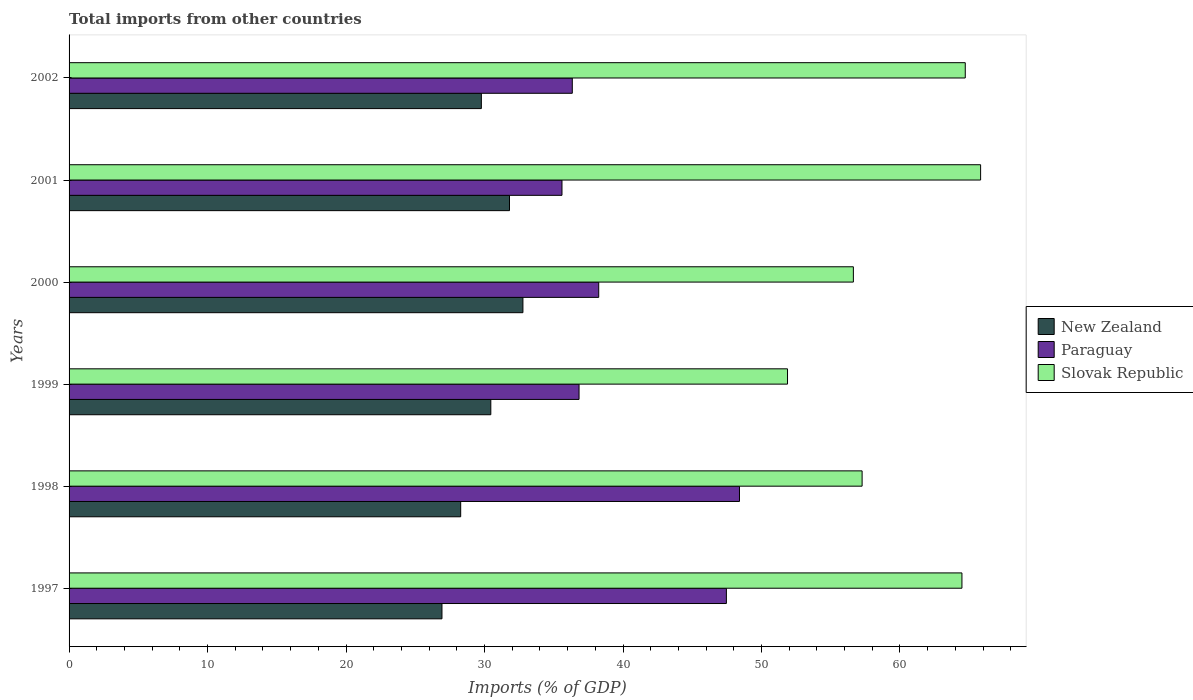How many groups of bars are there?
Keep it short and to the point. 6. How many bars are there on the 2nd tick from the top?
Your answer should be compact. 3. In how many cases, is the number of bars for a given year not equal to the number of legend labels?
Give a very brief answer. 0. What is the total imports in Slovak Republic in 2000?
Offer a very short reply. 56.63. Across all years, what is the maximum total imports in Slovak Republic?
Offer a terse response. 65.82. Across all years, what is the minimum total imports in New Zealand?
Your response must be concise. 26.93. What is the total total imports in Paraguay in the graph?
Make the answer very short. 242.88. What is the difference between the total imports in Slovak Republic in 1999 and that in 2002?
Give a very brief answer. -12.84. What is the difference between the total imports in Paraguay in 2000 and the total imports in New Zealand in 1997?
Make the answer very short. 11.32. What is the average total imports in New Zealand per year?
Your answer should be compact. 30. In the year 1997, what is the difference between the total imports in Slovak Republic and total imports in New Zealand?
Your answer should be compact. 37.55. In how many years, is the total imports in Paraguay greater than 2 %?
Offer a terse response. 6. What is the ratio of the total imports in Slovak Republic in 1997 to that in 1999?
Ensure brevity in your answer.  1.24. What is the difference between the highest and the second highest total imports in New Zealand?
Your answer should be very brief. 0.97. What is the difference between the highest and the lowest total imports in Slovak Republic?
Your response must be concise. 13.94. What does the 1st bar from the top in 2001 represents?
Ensure brevity in your answer.  Slovak Republic. What does the 3rd bar from the bottom in 1999 represents?
Your answer should be very brief. Slovak Republic. How many bars are there?
Your answer should be compact. 18. Are all the bars in the graph horizontal?
Ensure brevity in your answer.  Yes. What is the difference between two consecutive major ticks on the X-axis?
Offer a very short reply. 10. Are the values on the major ticks of X-axis written in scientific E-notation?
Your answer should be compact. No. Does the graph contain any zero values?
Provide a succinct answer. No. Does the graph contain grids?
Your answer should be compact. No. Where does the legend appear in the graph?
Your answer should be very brief. Center right. What is the title of the graph?
Give a very brief answer. Total imports from other countries. What is the label or title of the X-axis?
Give a very brief answer. Imports (% of GDP). What is the label or title of the Y-axis?
Offer a very short reply. Years. What is the Imports (% of GDP) in New Zealand in 1997?
Make the answer very short. 26.93. What is the Imports (% of GDP) of Paraguay in 1997?
Offer a terse response. 47.46. What is the Imports (% of GDP) of Slovak Republic in 1997?
Your answer should be very brief. 64.47. What is the Imports (% of GDP) in New Zealand in 1998?
Make the answer very short. 28.28. What is the Imports (% of GDP) in Paraguay in 1998?
Your answer should be very brief. 48.41. What is the Imports (% of GDP) in Slovak Republic in 1998?
Your response must be concise. 57.27. What is the Imports (% of GDP) in New Zealand in 1999?
Your answer should be very brief. 30.45. What is the Imports (% of GDP) in Paraguay in 1999?
Give a very brief answer. 36.83. What is the Imports (% of GDP) in Slovak Republic in 1999?
Offer a very short reply. 51.88. What is the Imports (% of GDP) in New Zealand in 2000?
Provide a succinct answer. 32.77. What is the Imports (% of GDP) of Paraguay in 2000?
Offer a terse response. 38.25. What is the Imports (% of GDP) of Slovak Republic in 2000?
Offer a terse response. 56.63. What is the Imports (% of GDP) in New Zealand in 2001?
Your answer should be compact. 31.8. What is the Imports (% of GDP) in Paraguay in 2001?
Offer a terse response. 35.59. What is the Imports (% of GDP) of Slovak Republic in 2001?
Provide a succinct answer. 65.82. What is the Imports (% of GDP) in New Zealand in 2002?
Provide a short and direct response. 29.77. What is the Imports (% of GDP) in Paraguay in 2002?
Offer a very short reply. 36.34. What is the Imports (% of GDP) of Slovak Republic in 2002?
Offer a terse response. 64.71. Across all years, what is the maximum Imports (% of GDP) of New Zealand?
Your response must be concise. 32.77. Across all years, what is the maximum Imports (% of GDP) in Paraguay?
Your response must be concise. 48.41. Across all years, what is the maximum Imports (% of GDP) of Slovak Republic?
Ensure brevity in your answer.  65.82. Across all years, what is the minimum Imports (% of GDP) in New Zealand?
Your response must be concise. 26.93. Across all years, what is the minimum Imports (% of GDP) of Paraguay?
Provide a succinct answer. 35.59. Across all years, what is the minimum Imports (% of GDP) of Slovak Republic?
Your answer should be very brief. 51.88. What is the total Imports (% of GDP) of New Zealand in the graph?
Make the answer very short. 180. What is the total Imports (% of GDP) of Paraguay in the graph?
Ensure brevity in your answer.  242.88. What is the total Imports (% of GDP) in Slovak Republic in the graph?
Provide a succinct answer. 360.78. What is the difference between the Imports (% of GDP) in New Zealand in 1997 and that in 1998?
Offer a terse response. -1.35. What is the difference between the Imports (% of GDP) in Paraguay in 1997 and that in 1998?
Provide a succinct answer. -0.95. What is the difference between the Imports (% of GDP) of Slovak Republic in 1997 and that in 1998?
Provide a short and direct response. 7.21. What is the difference between the Imports (% of GDP) in New Zealand in 1997 and that in 1999?
Ensure brevity in your answer.  -3.53. What is the difference between the Imports (% of GDP) of Paraguay in 1997 and that in 1999?
Provide a succinct answer. 10.64. What is the difference between the Imports (% of GDP) of Slovak Republic in 1997 and that in 1999?
Keep it short and to the point. 12.6. What is the difference between the Imports (% of GDP) of New Zealand in 1997 and that in 2000?
Your response must be concise. -5.85. What is the difference between the Imports (% of GDP) of Paraguay in 1997 and that in 2000?
Provide a short and direct response. 9.22. What is the difference between the Imports (% of GDP) of Slovak Republic in 1997 and that in 2000?
Provide a succinct answer. 7.84. What is the difference between the Imports (% of GDP) of New Zealand in 1997 and that in 2001?
Give a very brief answer. -4.88. What is the difference between the Imports (% of GDP) of Paraguay in 1997 and that in 2001?
Keep it short and to the point. 11.87. What is the difference between the Imports (% of GDP) in Slovak Republic in 1997 and that in 2001?
Ensure brevity in your answer.  -1.35. What is the difference between the Imports (% of GDP) of New Zealand in 1997 and that in 2002?
Provide a short and direct response. -2.85. What is the difference between the Imports (% of GDP) in Paraguay in 1997 and that in 2002?
Provide a short and direct response. 11.13. What is the difference between the Imports (% of GDP) of Slovak Republic in 1997 and that in 2002?
Provide a succinct answer. -0.24. What is the difference between the Imports (% of GDP) in New Zealand in 1998 and that in 1999?
Keep it short and to the point. -2.18. What is the difference between the Imports (% of GDP) of Paraguay in 1998 and that in 1999?
Provide a short and direct response. 11.58. What is the difference between the Imports (% of GDP) of Slovak Republic in 1998 and that in 1999?
Offer a very short reply. 5.39. What is the difference between the Imports (% of GDP) of New Zealand in 1998 and that in 2000?
Your response must be concise. -4.49. What is the difference between the Imports (% of GDP) in Paraguay in 1998 and that in 2000?
Provide a short and direct response. 10.16. What is the difference between the Imports (% of GDP) of Slovak Republic in 1998 and that in 2000?
Keep it short and to the point. 0.63. What is the difference between the Imports (% of GDP) in New Zealand in 1998 and that in 2001?
Offer a terse response. -3.52. What is the difference between the Imports (% of GDP) of Paraguay in 1998 and that in 2001?
Your answer should be very brief. 12.82. What is the difference between the Imports (% of GDP) of Slovak Republic in 1998 and that in 2001?
Offer a very short reply. -8.56. What is the difference between the Imports (% of GDP) in New Zealand in 1998 and that in 2002?
Offer a very short reply. -1.49. What is the difference between the Imports (% of GDP) in Paraguay in 1998 and that in 2002?
Your answer should be very brief. 12.07. What is the difference between the Imports (% of GDP) of Slovak Republic in 1998 and that in 2002?
Provide a short and direct response. -7.45. What is the difference between the Imports (% of GDP) in New Zealand in 1999 and that in 2000?
Make the answer very short. -2.32. What is the difference between the Imports (% of GDP) in Paraguay in 1999 and that in 2000?
Make the answer very short. -1.42. What is the difference between the Imports (% of GDP) of Slovak Republic in 1999 and that in 2000?
Offer a very short reply. -4.76. What is the difference between the Imports (% of GDP) of New Zealand in 1999 and that in 2001?
Provide a succinct answer. -1.35. What is the difference between the Imports (% of GDP) in Paraguay in 1999 and that in 2001?
Give a very brief answer. 1.23. What is the difference between the Imports (% of GDP) in Slovak Republic in 1999 and that in 2001?
Offer a very short reply. -13.94. What is the difference between the Imports (% of GDP) of New Zealand in 1999 and that in 2002?
Your answer should be compact. 0.68. What is the difference between the Imports (% of GDP) of Paraguay in 1999 and that in 2002?
Offer a very short reply. 0.49. What is the difference between the Imports (% of GDP) of Slovak Republic in 1999 and that in 2002?
Offer a terse response. -12.84. What is the difference between the Imports (% of GDP) of New Zealand in 2000 and that in 2001?
Offer a terse response. 0.97. What is the difference between the Imports (% of GDP) of Paraguay in 2000 and that in 2001?
Provide a short and direct response. 2.65. What is the difference between the Imports (% of GDP) in Slovak Republic in 2000 and that in 2001?
Keep it short and to the point. -9.19. What is the difference between the Imports (% of GDP) of New Zealand in 2000 and that in 2002?
Your answer should be compact. 3. What is the difference between the Imports (% of GDP) of Paraguay in 2000 and that in 2002?
Offer a very short reply. 1.91. What is the difference between the Imports (% of GDP) of Slovak Republic in 2000 and that in 2002?
Your response must be concise. -8.08. What is the difference between the Imports (% of GDP) of New Zealand in 2001 and that in 2002?
Your answer should be very brief. 2.03. What is the difference between the Imports (% of GDP) of Paraguay in 2001 and that in 2002?
Your response must be concise. -0.74. What is the difference between the Imports (% of GDP) of Slovak Republic in 2001 and that in 2002?
Offer a terse response. 1.11. What is the difference between the Imports (% of GDP) in New Zealand in 1997 and the Imports (% of GDP) in Paraguay in 1998?
Keep it short and to the point. -21.48. What is the difference between the Imports (% of GDP) in New Zealand in 1997 and the Imports (% of GDP) in Slovak Republic in 1998?
Your response must be concise. -30.34. What is the difference between the Imports (% of GDP) of Paraguay in 1997 and the Imports (% of GDP) of Slovak Republic in 1998?
Offer a very short reply. -9.8. What is the difference between the Imports (% of GDP) of New Zealand in 1997 and the Imports (% of GDP) of Paraguay in 1999?
Provide a succinct answer. -9.9. What is the difference between the Imports (% of GDP) in New Zealand in 1997 and the Imports (% of GDP) in Slovak Republic in 1999?
Provide a short and direct response. -24.95. What is the difference between the Imports (% of GDP) of Paraguay in 1997 and the Imports (% of GDP) of Slovak Republic in 1999?
Your answer should be compact. -4.41. What is the difference between the Imports (% of GDP) in New Zealand in 1997 and the Imports (% of GDP) in Paraguay in 2000?
Give a very brief answer. -11.32. What is the difference between the Imports (% of GDP) in New Zealand in 1997 and the Imports (% of GDP) in Slovak Republic in 2000?
Your answer should be very brief. -29.71. What is the difference between the Imports (% of GDP) in Paraguay in 1997 and the Imports (% of GDP) in Slovak Republic in 2000?
Give a very brief answer. -9.17. What is the difference between the Imports (% of GDP) of New Zealand in 1997 and the Imports (% of GDP) of Paraguay in 2001?
Offer a very short reply. -8.67. What is the difference between the Imports (% of GDP) in New Zealand in 1997 and the Imports (% of GDP) in Slovak Republic in 2001?
Make the answer very short. -38.89. What is the difference between the Imports (% of GDP) of Paraguay in 1997 and the Imports (% of GDP) of Slovak Republic in 2001?
Ensure brevity in your answer.  -18.36. What is the difference between the Imports (% of GDP) of New Zealand in 1997 and the Imports (% of GDP) of Paraguay in 2002?
Your response must be concise. -9.41. What is the difference between the Imports (% of GDP) in New Zealand in 1997 and the Imports (% of GDP) in Slovak Republic in 2002?
Provide a succinct answer. -37.79. What is the difference between the Imports (% of GDP) in Paraguay in 1997 and the Imports (% of GDP) in Slovak Republic in 2002?
Make the answer very short. -17.25. What is the difference between the Imports (% of GDP) in New Zealand in 1998 and the Imports (% of GDP) in Paraguay in 1999?
Your response must be concise. -8.55. What is the difference between the Imports (% of GDP) in New Zealand in 1998 and the Imports (% of GDP) in Slovak Republic in 1999?
Give a very brief answer. -23.6. What is the difference between the Imports (% of GDP) in Paraguay in 1998 and the Imports (% of GDP) in Slovak Republic in 1999?
Your answer should be compact. -3.47. What is the difference between the Imports (% of GDP) of New Zealand in 1998 and the Imports (% of GDP) of Paraguay in 2000?
Provide a succinct answer. -9.97. What is the difference between the Imports (% of GDP) in New Zealand in 1998 and the Imports (% of GDP) in Slovak Republic in 2000?
Keep it short and to the point. -28.36. What is the difference between the Imports (% of GDP) of Paraguay in 1998 and the Imports (% of GDP) of Slovak Republic in 2000?
Offer a terse response. -8.22. What is the difference between the Imports (% of GDP) in New Zealand in 1998 and the Imports (% of GDP) in Paraguay in 2001?
Your answer should be compact. -7.31. What is the difference between the Imports (% of GDP) of New Zealand in 1998 and the Imports (% of GDP) of Slovak Republic in 2001?
Offer a terse response. -37.54. What is the difference between the Imports (% of GDP) in Paraguay in 1998 and the Imports (% of GDP) in Slovak Republic in 2001?
Your answer should be very brief. -17.41. What is the difference between the Imports (% of GDP) in New Zealand in 1998 and the Imports (% of GDP) in Paraguay in 2002?
Offer a very short reply. -8.06. What is the difference between the Imports (% of GDP) of New Zealand in 1998 and the Imports (% of GDP) of Slovak Republic in 2002?
Your answer should be very brief. -36.44. What is the difference between the Imports (% of GDP) of Paraguay in 1998 and the Imports (% of GDP) of Slovak Republic in 2002?
Offer a terse response. -16.3. What is the difference between the Imports (% of GDP) in New Zealand in 1999 and the Imports (% of GDP) in Paraguay in 2000?
Ensure brevity in your answer.  -7.79. What is the difference between the Imports (% of GDP) of New Zealand in 1999 and the Imports (% of GDP) of Slovak Republic in 2000?
Make the answer very short. -26.18. What is the difference between the Imports (% of GDP) of Paraguay in 1999 and the Imports (% of GDP) of Slovak Republic in 2000?
Ensure brevity in your answer.  -19.81. What is the difference between the Imports (% of GDP) in New Zealand in 1999 and the Imports (% of GDP) in Paraguay in 2001?
Give a very brief answer. -5.14. What is the difference between the Imports (% of GDP) of New Zealand in 1999 and the Imports (% of GDP) of Slovak Republic in 2001?
Provide a succinct answer. -35.37. What is the difference between the Imports (% of GDP) of Paraguay in 1999 and the Imports (% of GDP) of Slovak Republic in 2001?
Offer a terse response. -29. What is the difference between the Imports (% of GDP) in New Zealand in 1999 and the Imports (% of GDP) in Paraguay in 2002?
Offer a very short reply. -5.88. What is the difference between the Imports (% of GDP) of New Zealand in 1999 and the Imports (% of GDP) of Slovak Republic in 2002?
Give a very brief answer. -34.26. What is the difference between the Imports (% of GDP) of Paraguay in 1999 and the Imports (% of GDP) of Slovak Republic in 2002?
Keep it short and to the point. -27.89. What is the difference between the Imports (% of GDP) in New Zealand in 2000 and the Imports (% of GDP) in Paraguay in 2001?
Ensure brevity in your answer.  -2.82. What is the difference between the Imports (% of GDP) in New Zealand in 2000 and the Imports (% of GDP) in Slovak Republic in 2001?
Your response must be concise. -33.05. What is the difference between the Imports (% of GDP) of Paraguay in 2000 and the Imports (% of GDP) of Slovak Republic in 2001?
Offer a very short reply. -27.58. What is the difference between the Imports (% of GDP) of New Zealand in 2000 and the Imports (% of GDP) of Paraguay in 2002?
Keep it short and to the point. -3.57. What is the difference between the Imports (% of GDP) in New Zealand in 2000 and the Imports (% of GDP) in Slovak Republic in 2002?
Your response must be concise. -31.94. What is the difference between the Imports (% of GDP) of Paraguay in 2000 and the Imports (% of GDP) of Slovak Republic in 2002?
Ensure brevity in your answer.  -26.47. What is the difference between the Imports (% of GDP) in New Zealand in 2001 and the Imports (% of GDP) in Paraguay in 2002?
Offer a terse response. -4.53. What is the difference between the Imports (% of GDP) in New Zealand in 2001 and the Imports (% of GDP) in Slovak Republic in 2002?
Make the answer very short. -32.91. What is the difference between the Imports (% of GDP) in Paraguay in 2001 and the Imports (% of GDP) in Slovak Republic in 2002?
Offer a very short reply. -29.12. What is the average Imports (% of GDP) of New Zealand per year?
Your answer should be compact. 30. What is the average Imports (% of GDP) of Paraguay per year?
Make the answer very short. 40.48. What is the average Imports (% of GDP) in Slovak Republic per year?
Provide a succinct answer. 60.13. In the year 1997, what is the difference between the Imports (% of GDP) in New Zealand and Imports (% of GDP) in Paraguay?
Your answer should be compact. -20.54. In the year 1997, what is the difference between the Imports (% of GDP) of New Zealand and Imports (% of GDP) of Slovak Republic?
Provide a short and direct response. -37.55. In the year 1997, what is the difference between the Imports (% of GDP) in Paraguay and Imports (% of GDP) in Slovak Republic?
Your answer should be compact. -17.01. In the year 1998, what is the difference between the Imports (% of GDP) of New Zealand and Imports (% of GDP) of Paraguay?
Your answer should be very brief. -20.13. In the year 1998, what is the difference between the Imports (% of GDP) in New Zealand and Imports (% of GDP) in Slovak Republic?
Provide a succinct answer. -28.99. In the year 1998, what is the difference between the Imports (% of GDP) in Paraguay and Imports (% of GDP) in Slovak Republic?
Your answer should be compact. -8.86. In the year 1999, what is the difference between the Imports (% of GDP) in New Zealand and Imports (% of GDP) in Paraguay?
Ensure brevity in your answer.  -6.37. In the year 1999, what is the difference between the Imports (% of GDP) of New Zealand and Imports (% of GDP) of Slovak Republic?
Offer a terse response. -21.42. In the year 1999, what is the difference between the Imports (% of GDP) of Paraguay and Imports (% of GDP) of Slovak Republic?
Your response must be concise. -15.05. In the year 2000, what is the difference between the Imports (% of GDP) of New Zealand and Imports (% of GDP) of Paraguay?
Provide a short and direct response. -5.47. In the year 2000, what is the difference between the Imports (% of GDP) in New Zealand and Imports (% of GDP) in Slovak Republic?
Offer a very short reply. -23.86. In the year 2000, what is the difference between the Imports (% of GDP) in Paraguay and Imports (% of GDP) in Slovak Republic?
Keep it short and to the point. -18.39. In the year 2001, what is the difference between the Imports (% of GDP) of New Zealand and Imports (% of GDP) of Paraguay?
Ensure brevity in your answer.  -3.79. In the year 2001, what is the difference between the Imports (% of GDP) in New Zealand and Imports (% of GDP) in Slovak Republic?
Give a very brief answer. -34.02. In the year 2001, what is the difference between the Imports (% of GDP) of Paraguay and Imports (% of GDP) of Slovak Republic?
Your response must be concise. -30.23. In the year 2002, what is the difference between the Imports (% of GDP) of New Zealand and Imports (% of GDP) of Paraguay?
Your response must be concise. -6.57. In the year 2002, what is the difference between the Imports (% of GDP) in New Zealand and Imports (% of GDP) in Slovak Republic?
Ensure brevity in your answer.  -34.94. In the year 2002, what is the difference between the Imports (% of GDP) in Paraguay and Imports (% of GDP) in Slovak Republic?
Your answer should be very brief. -28.38. What is the ratio of the Imports (% of GDP) in New Zealand in 1997 to that in 1998?
Provide a succinct answer. 0.95. What is the ratio of the Imports (% of GDP) in Paraguay in 1997 to that in 1998?
Provide a short and direct response. 0.98. What is the ratio of the Imports (% of GDP) of Slovak Republic in 1997 to that in 1998?
Provide a short and direct response. 1.13. What is the ratio of the Imports (% of GDP) in New Zealand in 1997 to that in 1999?
Ensure brevity in your answer.  0.88. What is the ratio of the Imports (% of GDP) of Paraguay in 1997 to that in 1999?
Your answer should be compact. 1.29. What is the ratio of the Imports (% of GDP) in Slovak Republic in 1997 to that in 1999?
Your answer should be compact. 1.24. What is the ratio of the Imports (% of GDP) in New Zealand in 1997 to that in 2000?
Keep it short and to the point. 0.82. What is the ratio of the Imports (% of GDP) in Paraguay in 1997 to that in 2000?
Keep it short and to the point. 1.24. What is the ratio of the Imports (% of GDP) in Slovak Republic in 1997 to that in 2000?
Your response must be concise. 1.14. What is the ratio of the Imports (% of GDP) of New Zealand in 1997 to that in 2001?
Your answer should be compact. 0.85. What is the ratio of the Imports (% of GDP) in Paraguay in 1997 to that in 2001?
Provide a succinct answer. 1.33. What is the ratio of the Imports (% of GDP) in Slovak Republic in 1997 to that in 2001?
Your answer should be compact. 0.98. What is the ratio of the Imports (% of GDP) in New Zealand in 1997 to that in 2002?
Your response must be concise. 0.9. What is the ratio of the Imports (% of GDP) of Paraguay in 1997 to that in 2002?
Provide a succinct answer. 1.31. What is the ratio of the Imports (% of GDP) of Slovak Republic in 1997 to that in 2002?
Keep it short and to the point. 1. What is the ratio of the Imports (% of GDP) of Paraguay in 1998 to that in 1999?
Offer a terse response. 1.31. What is the ratio of the Imports (% of GDP) of Slovak Republic in 1998 to that in 1999?
Keep it short and to the point. 1.1. What is the ratio of the Imports (% of GDP) in New Zealand in 1998 to that in 2000?
Offer a very short reply. 0.86. What is the ratio of the Imports (% of GDP) of Paraguay in 1998 to that in 2000?
Make the answer very short. 1.27. What is the ratio of the Imports (% of GDP) in Slovak Republic in 1998 to that in 2000?
Your answer should be compact. 1.01. What is the ratio of the Imports (% of GDP) in New Zealand in 1998 to that in 2001?
Your answer should be compact. 0.89. What is the ratio of the Imports (% of GDP) of Paraguay in 1998 to that in 2001?
Provide a short and direct response. 1.36. What is the ratio of the Imports (% of GDP) of Slovak Republic in 1998 to that in 2001?
Provide a short and direct response. 0.87. What is the ratio of the Imports (% of GDP) of New Zealand in 1998 to that in 2002?
Keep it short and to the point. 0.95. What is the ratio of the Imports (% of GDP) of Paraguay in 1998 to that in 2002?
Your answer should be very brief. 1.33. What is the ratio of the Imports (% of GDP) in Slovak Republic in 1998 to that in 2002?
Your answer should be very brief. 0.88. What is the ratio of the Imports (% of GDP) of New Zealand in 1999 to that in 2000?
Your response must be concise. 0.93. What is the ratio of the Imports (% of GDP) in Paraguay in 1999 to that in 2000?
Give a very brief answer. 0.96. What is the ratio of the Imports (% of GDP) in Slovak Republic in 1999 to that in 2000?
Your response must be concise. 0.92. What is the ratio of the Imports (% of GDP) of New Zealand in 1999 to that in 2001?
Keep it short and to the point. 0.96. What is the ratio of the Imports (% of GDP) in Paraguay in 1999 to that in 2001?
Ensure brevity in your answer.  1.03. What is the ratio of the Imports (% of GDP) of Slovak Republic in 1999 to that in 2001?
Give a very brief answer. 0.79. What is the ratio of the Imports (% of GDP) of New Zealand in 1999 to that in 2002?
Offer a terse response. 1.02. What is the ratio of the Imports (% of GDP) of Paraguay in 1999 to that in 2002?
Provide a short and direct response. 1.01. What is the ratio of the Imports (% of GDP) of Slovak Republic in 1999 to that in 2002?
Offer a terse response. 0.8. What is the ratio of the Imports (% of GDP) in New Zealand in 2000 to that in 2001?
Give a very brief answer. 1.03. What is the ratio of the Imports (% of GDP) of Paraguay in 2000 to that in 2001?
Ensure brevity in your answer.  1.07. What is the ratio of the Imports (% of GDP) in Slovak Republic in 2000 to that in 2001?
Make the answer very short. 0.86. What is the ratio of the Imports (% of GDP) of New Zealand in 2000 to that in 2002?
Give a very brief answer. 1.1. What is the ratio of the Imports (% of GDP) of Paraguay in 2000 to that in 2002?
Your response must be concise. 1.05. What is the ratio of the Imports (% of GDP) in Slovak Republic in 2000 to that in 2002?
Your answer should be compact. 0.88. What is the ratio of the Imports (% of GDP) of New Zealand in 2001 to that in 2002?
Give a very brief answer. 1.07. What is the ratio of the Imports (% of GDP) of Paraguay in 2001 to that in 2002?
Keep it short and to the point. 0.98. What is the ratio of the Imports (% of GDP) in Slovak Republic in 2001 to that in 2002?
Your answer should be compact. 1.02. What is the difference between the highest and the second highest Imports (% of GDP) in New Zealand?
Give a very brief answer. 0.97. What is the difference between the highest and the second highest Imports (% of GDP) in Paraguay?
Keep it short and to the point. 0.95. What is the difference between the highest and the second highest Imports (% of GDP) in Slovak Republic?
Offer a very short reply. 1.11. What is the difference between the highest and the lowest Imports (% of GDP) of New Zealand?
Give a very brief answer. 5.85. What is the difference between the highest and the lowest Imports (% of GDP) of Paraguay?
Keep it short and to the point. 12.82. What is the difference between the highest and the lowest Imports (% of GDP) in Slovak Republic?
Keep it short and to the point. 13.94. 